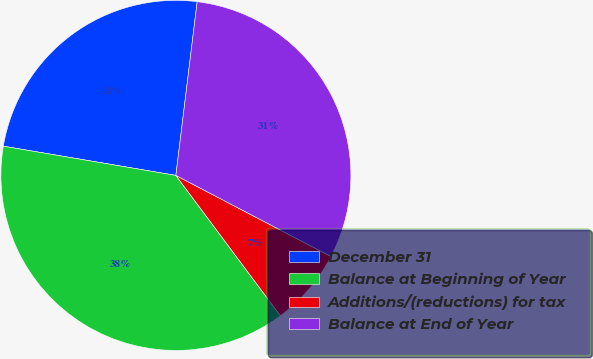Convert chart to OTSL. <chart><loc_0><loc_0><loc_500><loc_500><pie_chart><fcel>December 31<fcel>Balance at Beginning of Year<fcel>Additions/(reductions) for tax<fcel>Balance at End of Year<nl><fcel>24.27%<fcel>37.86%<fcel>7.14%<fcel>30.72%<nl></chart> 